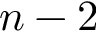Convert formula to latex. <formula><loc_0><loc_0><loc_500><loc_500>n - 2</formula> 